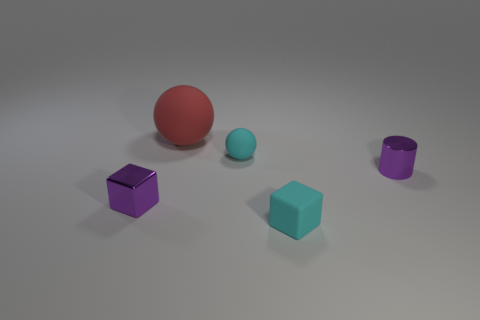Add 2 tiny cyan shiny spheres. How many objects exist? 7 Subtract all cylinders. How many objects are left? 4 Subtract all small cyan matte cubes. Subtract all cyan spheres. How many objects are left? 3 Add 1 big red rubber objects. How many big red rubber objects are left? 2 Add 1 large purple matte blocks. How many large purple matte blocks exist? 1 Subtract 0 yellow spheres. How many objects are left? 5 